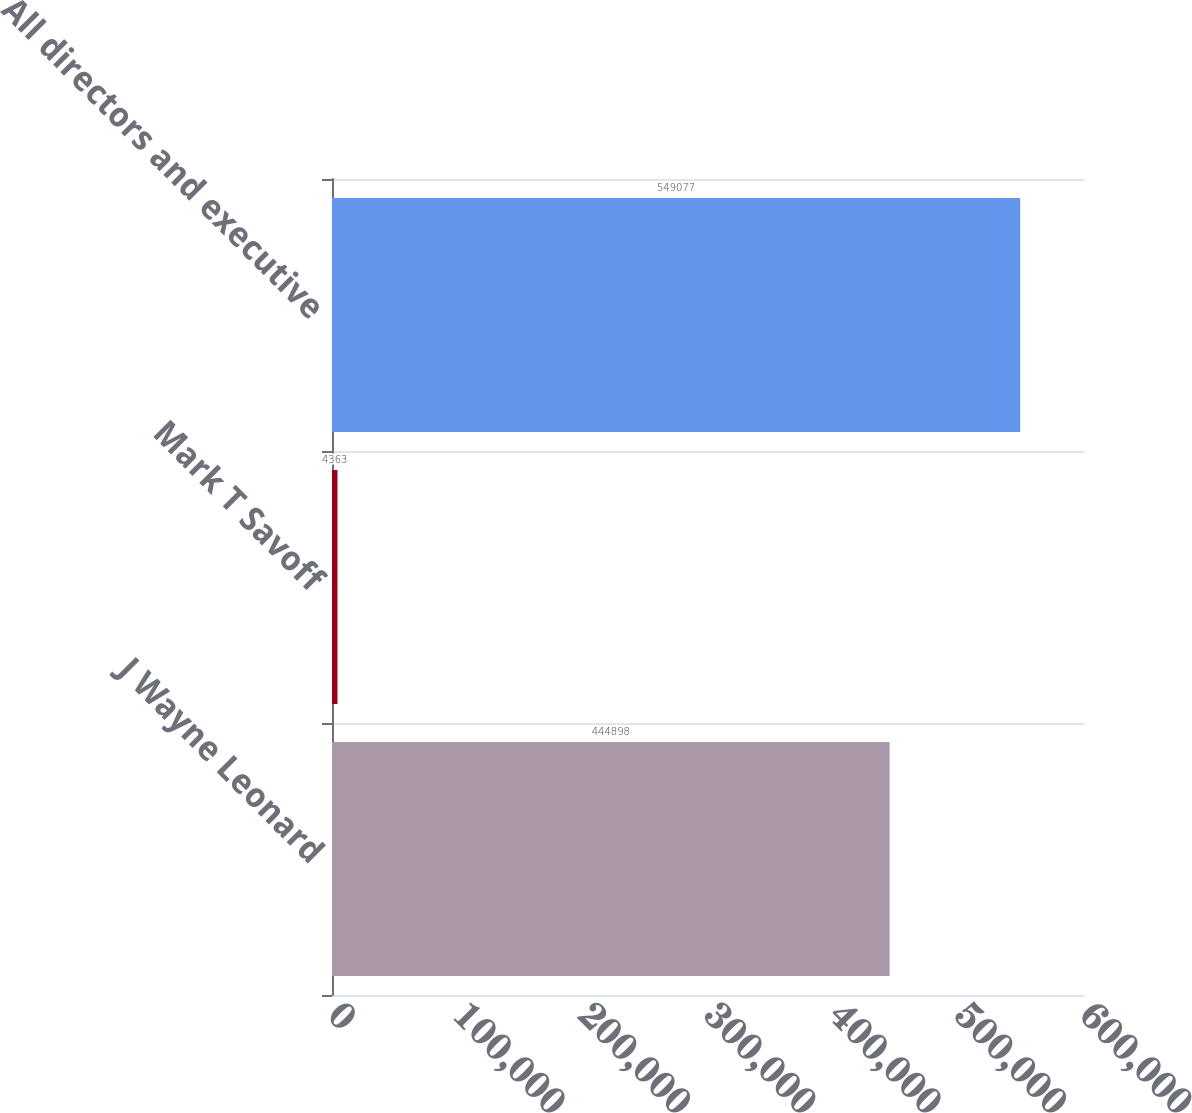Convert chart. <chart><loc_0><loc_0><loc_500><loc_500><bar_chart><fcel>J Wayne Leonard<fcel>Mark T Savoff<fcel>All directors and executive<nl><fcel>444898<fcel>4363<fcel>549077<nl></chart> 